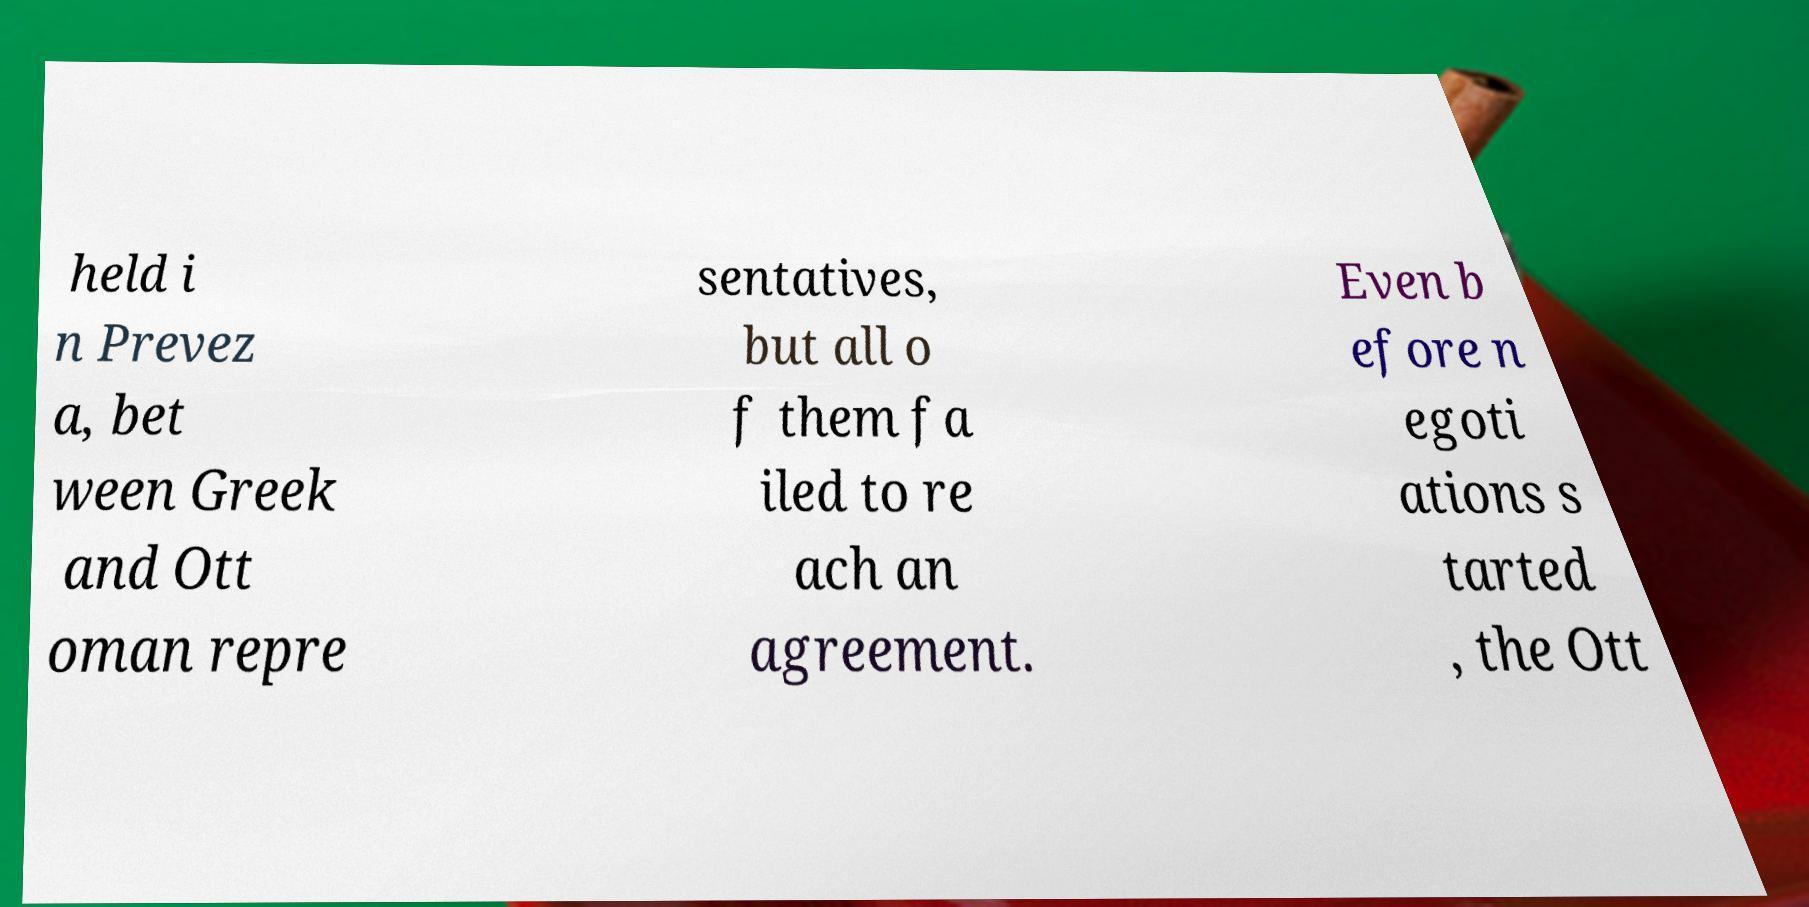Can you accurately transcribe the text from the provided image for me? held i n Prevez a, bet ween Greek and Ott oman repre sentatives, but all o f them fa iled to re ach an agreement. Even b efore n egoti ations s tarted , the Ott 